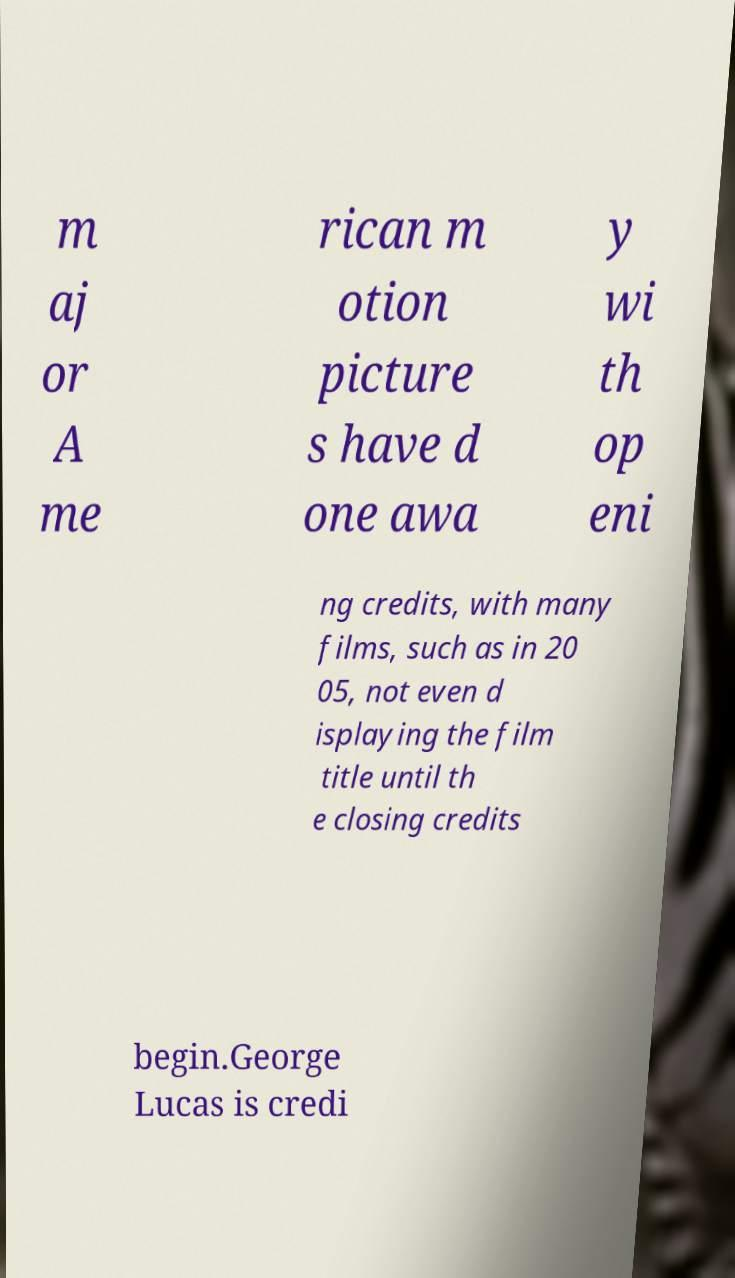There's text embedded in this image that I need extracted. Can you transcribe it verbatim? m aj or A me rican m otion picture s have d one awa y wi th op eni ng credits, with many films, such as in 20 05, not even d isplaying the film title until th e closing credits begin.George Lucas is credi 